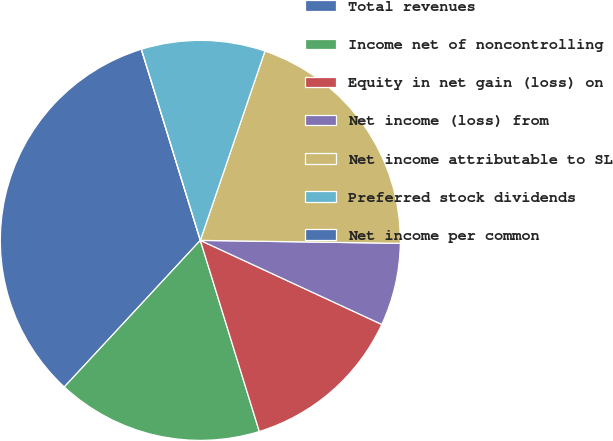<chart> <loc_0><loc_0><loc_500><loc_500><pie_chart><fcel>Total revenues<fcel>Income net of noncontrolling<fcel>Equity in net gain (loss) on<fcel>Net income (loss) from<fcel>Net income attributable to SL<fcel>Preferred stock dividends<fcel>Net income per common<nl><fcel>33.33%<fcel>16.67%<fcel>13.33%<fcel>6.67%<fcel>20.0%<fcel>10.0%<fcel>0.0%<nl></chart> 